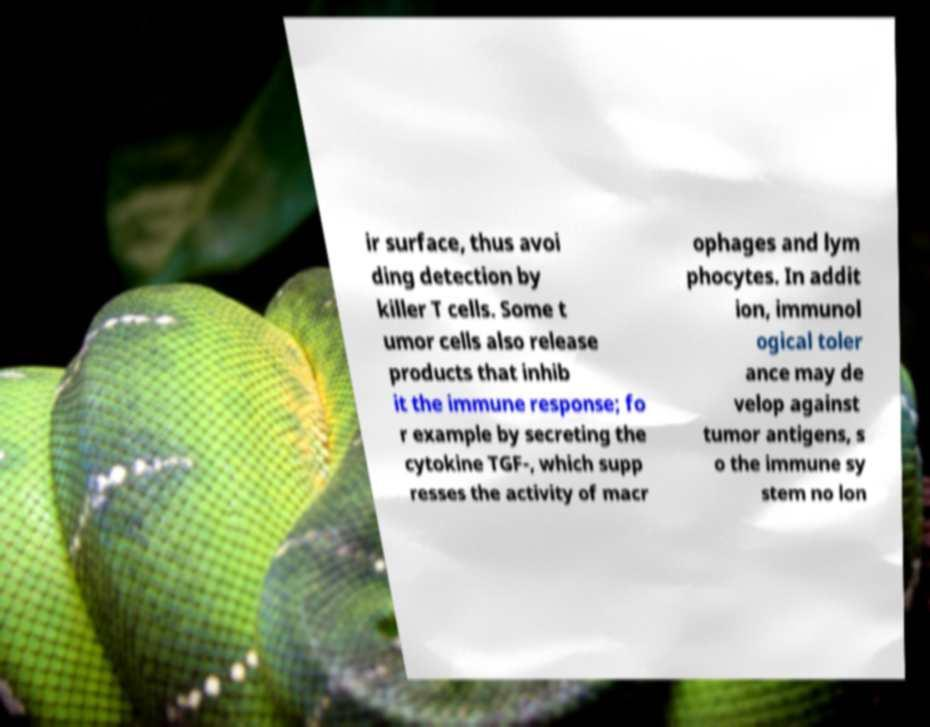For documentation purposes, I need the text within this image transcribed. Could you provide that? ir surface, thus avoi ding detection by killer T cells. Some t umor cells also release products that inhib it the immune response; fo r example by secreting the cytokine TGF-, which supp resses the activity of macr ophages and lym phocytes. In addit ion, immunol ogical toler ance may de velop against tumor antigens, s o the immune sy stem no lon 